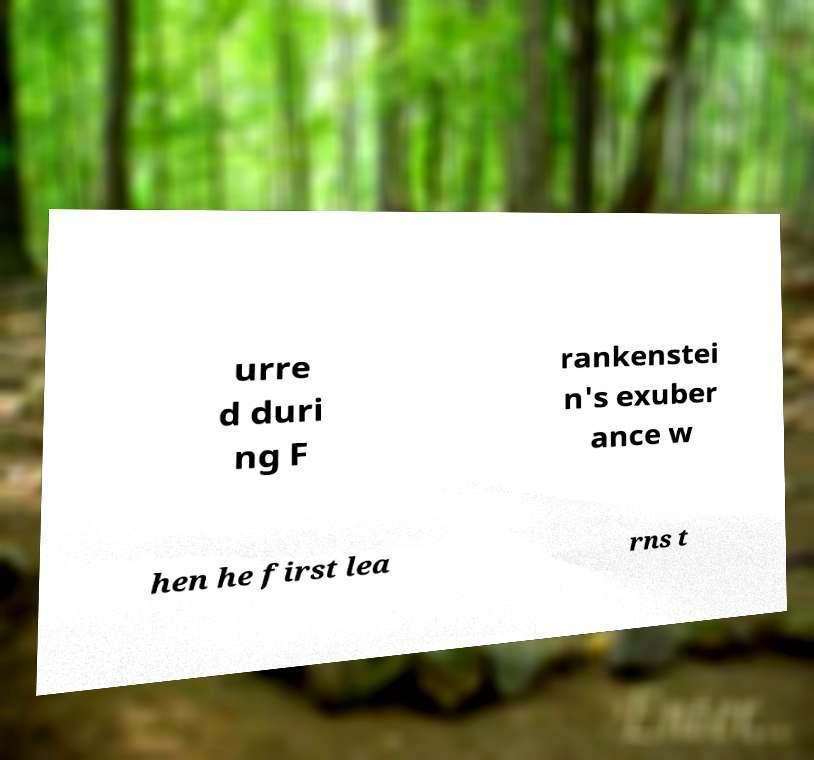Please identify and transcribe the text found in this image. urre d duri ng F rankenstei n's exuber ance w hen he first lea rns t 